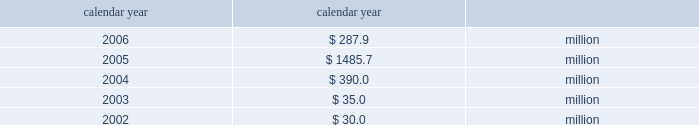Taxes .
If group or its bermuda subsidiaries were to become subject to u.s .
Income tax ; there could be a material adverse effect on the company 2019s financial condition , results of operations and cash flows .
United kingdom .
Bermuda re 2019s uk branch conducts business in the uk and is subject to taxation in the uk .
Bermuda re believes that it has operated and will continue to operate its bermuda operation in a manner which will not cause them to be subject to uk taxation .
If bermuda re 2019s bermuda operations were to become subject to uk income tax there could be a material adverse impact on the company 2019s financial condition , results of operations and cash flow .
Available information the company 2019s annual reports on form 10-k , quarterly reports on form 10-q , current reports on form 8-k , proxy state- ments and amendments to those reports are available free of charge through the company 2019s internet website at http://www.everestre.com as soon as reasonably practicable after such reports are electronically filed with the securities and exchange commission ( the 201csec 201d ) .
I t e m 1 a .
R i s k f a c t o r s in addition to the other information provided in this report , the following risk factors should be considered when evaluating an investment in our securities .
If the circumstances contemplated by the individual risk factors materialize , our business , finan- cial condition and results of operations could be materially and adversely affected and the trading price of our common shares could decline significantly .
R i s k s r e l a t i n g t o o u r b u s i n e s s our results could be adversely affected by catastrophic events .
We are exposed to unpredictable catastrophic events , including weather-related and other natural catastrophes , as well as acts of terrorism .
Any material reduction in our operating results caused by the occurrence of one or more catastrophes could inhibit our ability to pay dividends or to meet our interest and principal payment obligations .
We define a catastrophe as an event that causes a pre-tax loss on property exposures before reinsurance of at least $ 5.0 million , before corporate level rein- surance and taxes .
Effective for the third quarter 2005 , industrial risk losses have been excluded from catastrophe losses , with prior periods adjusted for comparison purposes .
By way of illustration , during the past five calendar years , pre-tax catastrophe losses , net of contract specific reinsurance but before cessions under corporate reinsurance programs , were as follows: .
Our losses from future catastrophic events could exceed our projections .
We use projections of possible losses from future catastrophic events of varying types and magnitudes as a strategic under- writing tool .
We use these loss projections to estimate our potential catastrophe losses in certain geographic areas and decide on the purchase of retrocessional coverage or other actions to limit the extent of potential losses in a given geographic area .
These loss projections are approximations reliant on a mix of quantitative and qualitative processes and actual losses may exceed the projections by a material amount .
We focus on potential losses that can be generated by any single event as part of our evaluation and monitoring of our aggre- gate exposure to catastrophic events .
Accordingly , we employ various techniques to estimate the amount of loss we could sustain from any single catastrophic event in various geographical areas .
These techniques range from non-modeled deterministic approaches 2014such as tracking aggregate limits exposed in catastrophe-prone zones and applying historic dam- age factors 2014to modeled approaches that scientifically measure catastrophe risks using sophisticated monte carlo simulation techniques that provide insights into the frequency and severity of expected losses on a probabilistic basis .
If our loss reserves are inadequate to meet our actual losses , net income would be reduced or we could incur a loss .
We are required to maintain reserves to cover our estimated ultimate liability of losses and loss adjustment expenses for both reported and unreported claims incurred .
These reserves are only estimates of what we believe the settlement and adminis- tration of claims will cost based on facts and circumstances known to us .
In setting reserves for our reinsurance liabilities , we rely on claim data supplied by our ceding companies and brokers and we employ actuarial and statistical projections .
The information received from our ceding companies is not always timely or accurate , which can contribute to inaccuracies in our 81790fin_a 4/13/07 11:08 am page 23 http://www.everestre.com .
What is the percentage change of the , pre-tax catastrophe losses from 2003 to 2004? 
Computations: (390.0 - 35.0)
Answer: 355.0. 